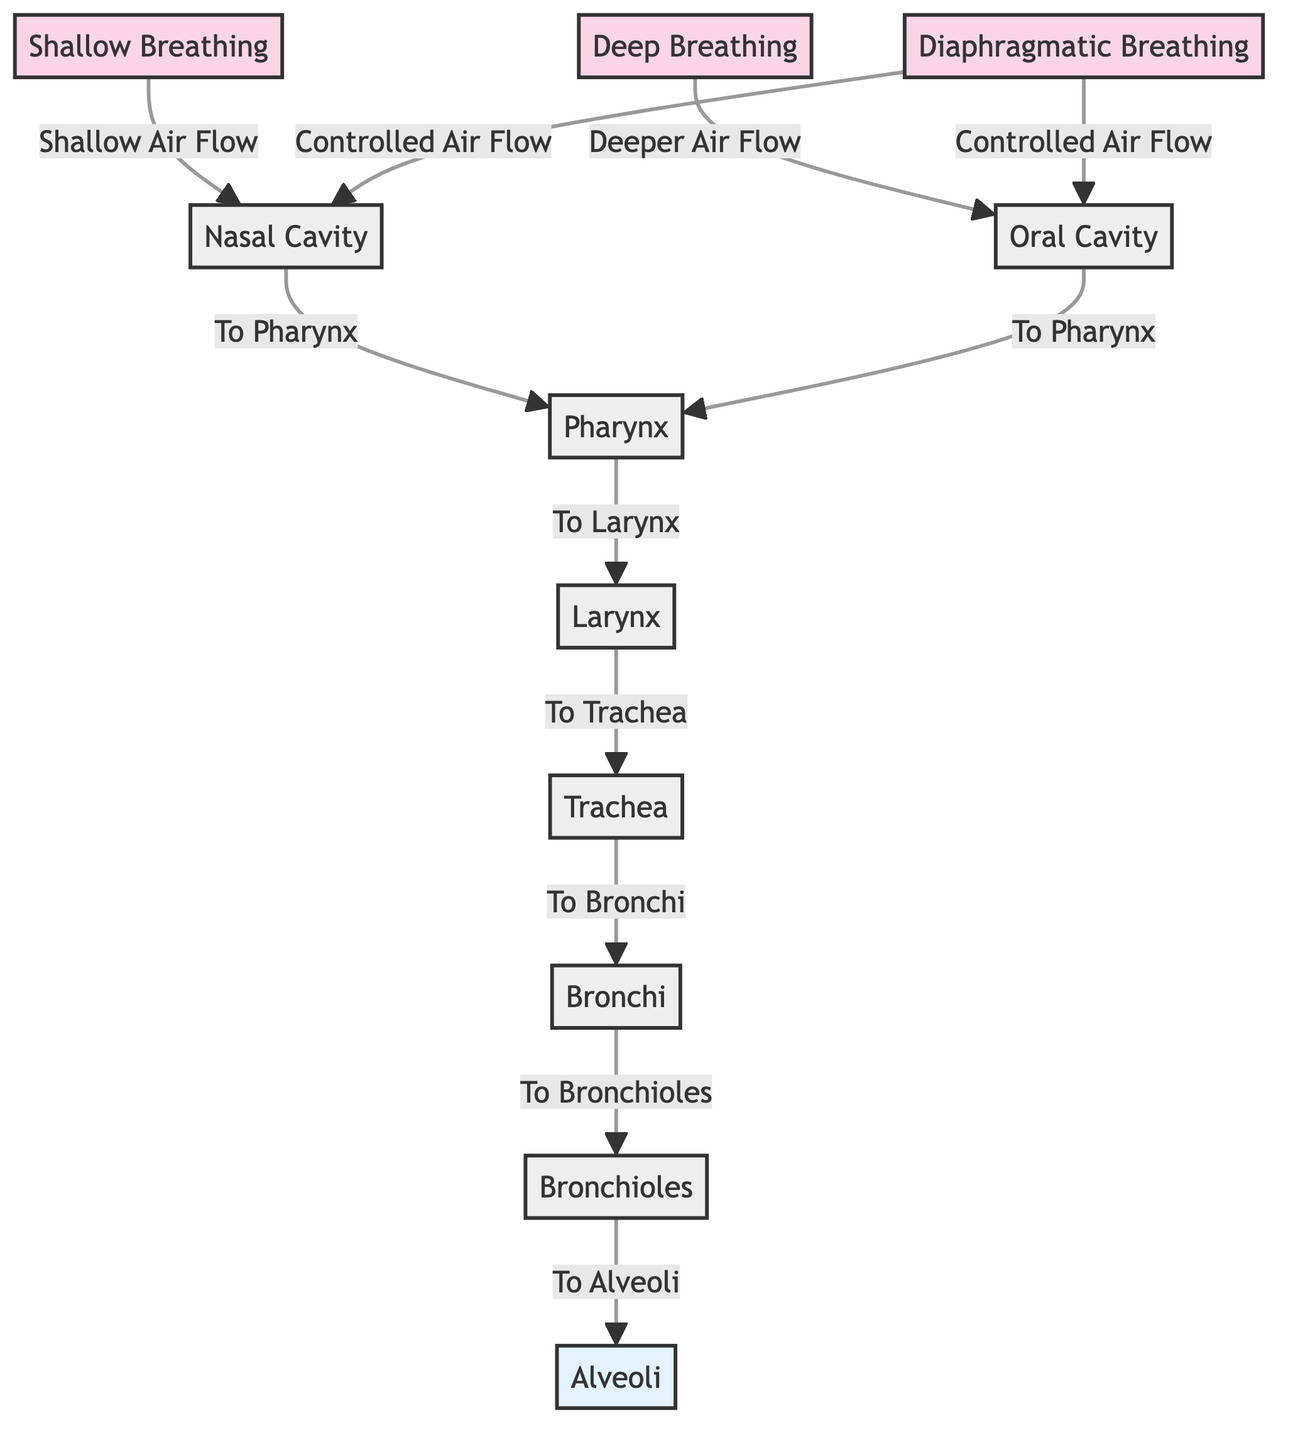What nodes are present in this diagram? The diagram includes the following nodes: Nasal Cavity, Oral Cavity, Pharynx, Larynx, Trachea, Bronchi, Bronchioles, Alveoli, Shallow Breathing, Deep Breathing, and Diaphragmatic Breathing.
Answer: Nasal Cavity, Oral Cavity, Pharynx, Larynx, Trachea, Bronchi, Bronchioles, Alveoli, Shallow Breathing, Deep Breathing, Diaphragmatic Breathing How many types of breathing exercises are represented in the diagram? There are three types of breathing exercises shown in the diagram: Shallow Breathing, Deep Breathing, and Diaphragmatic Breathing.
Answer: 3 What is the first airway node that shallow breathing leads to? According to the diagram, shallow breathing leads to the Nasal Cavity first.
Answer: Nasal Cavity Which breathing exercise connects to both nasal and oral cavities? The diagram shows that Diaphragmatic Breathing connects to both the Nasal Cavity and Oral Cavity.
Answer: Diaphragmatic Breathing What is the sequence of air flow after the Larynx? After the Larynx, the air flow sequence continues through the Trachea to the Bronchi, then to the Bronchioles, and finally to the Alveoli.
Answer: Trachea, Bronchi, Bronchioles, Alveoli What type of air flow is associated with deep breathing? The diagram indicates that deep breathing is associated with "Deeper Air Flow."
Answer: Deeper Air Flow Which exercise leads to controlled air flow into both nasal and oral cavities? Diaphragmatic Breathing leads to controlled air flow into both the Nasal Cavity and Oral Cavity as shown in the diagram.
Answer: Diaphragmatic Breathing How does the air flow from the Oral Cavity? The air flows from the Oral Cavity to the Pharynx as indicated by the arrow in the diagram.
Answer: To Pharynx What is the final destination of the air flow when shallow breathing is used? When shallow breathing is used, the final destination of the air flow is the Alveoli.
Answer: Alveoli 